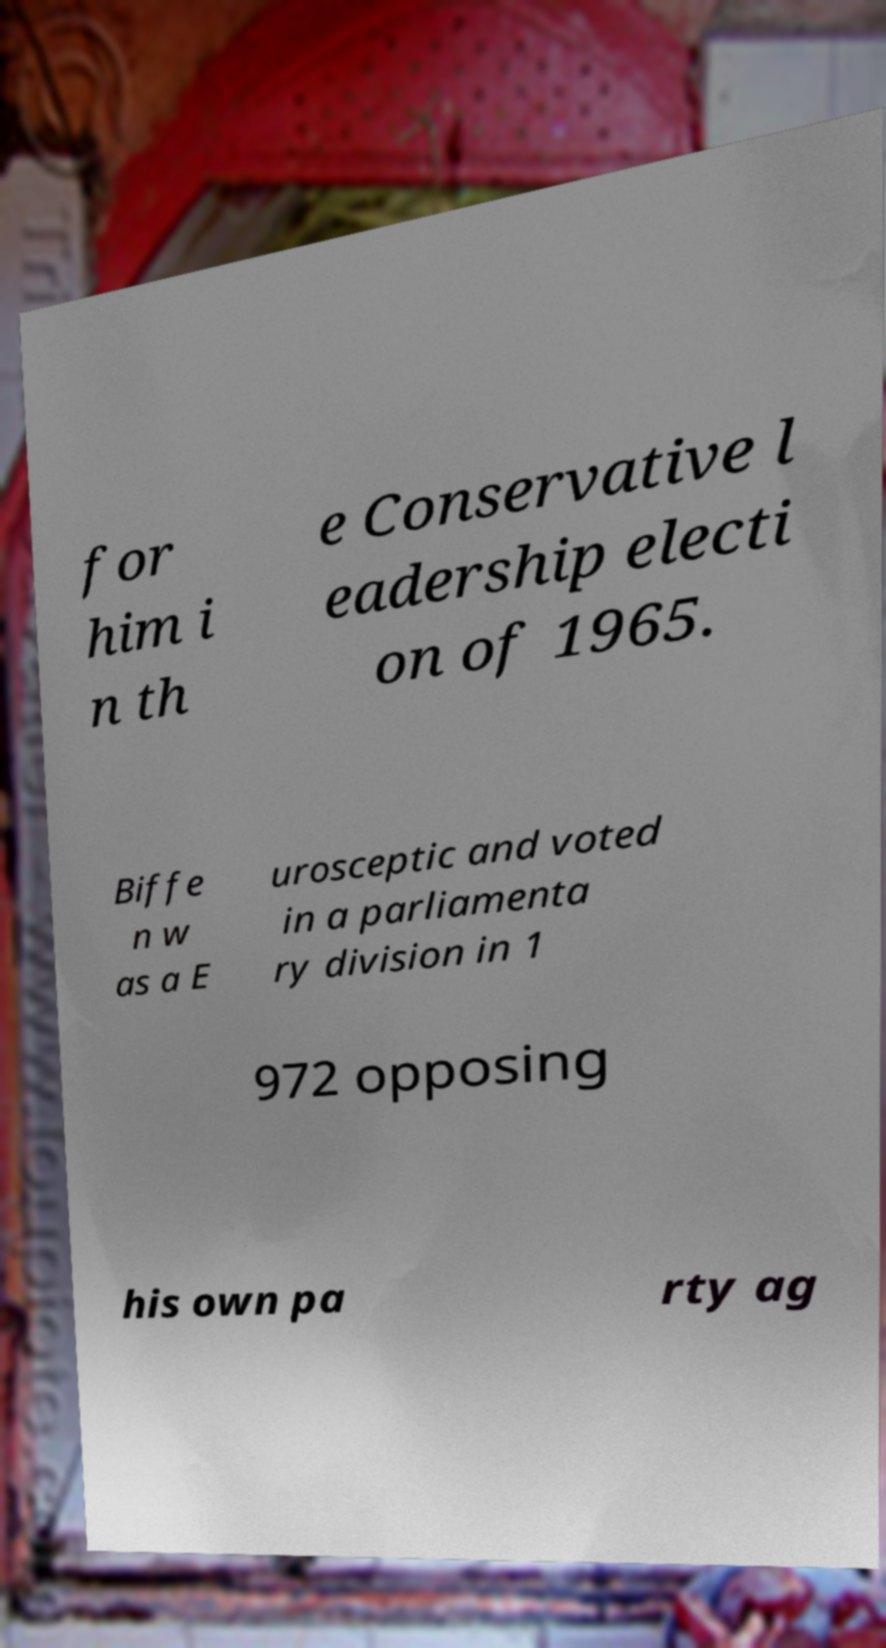Could you extract and type out the text from this image? for him i n th e Conservative l eadership electi on of 1965. Biffe n w as a E urosceptic and voted in a parliamenta ry division in 1 972 opposing his own pa rty ag 